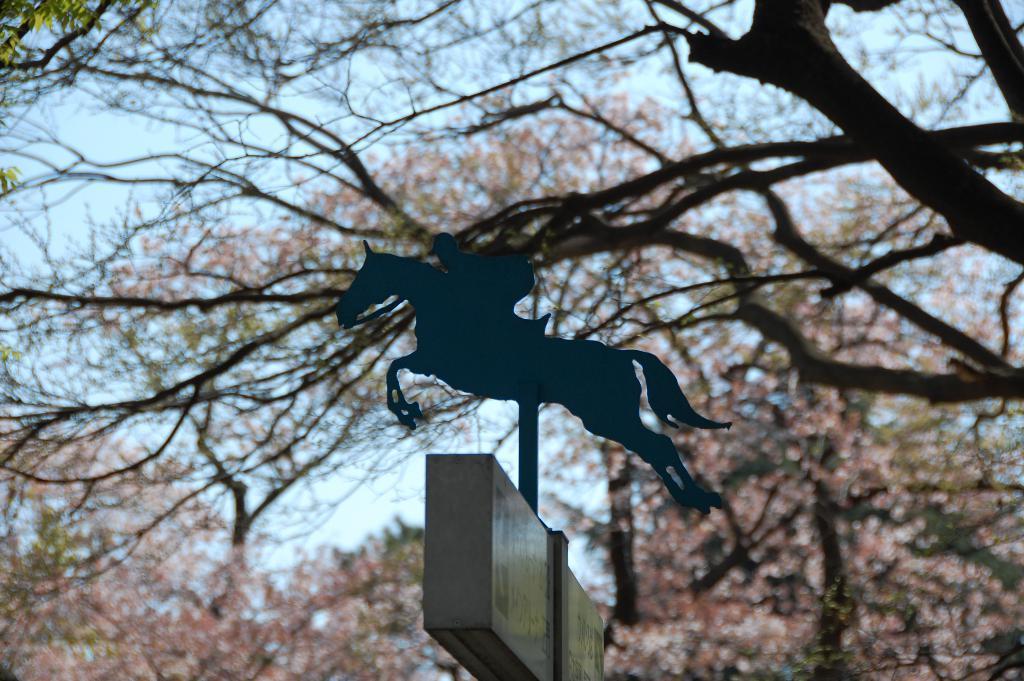Please provide a concise description of this image. In this picture we can see a board, pole, trees, logo of a person riding a horse and in the background we can see the sky. 